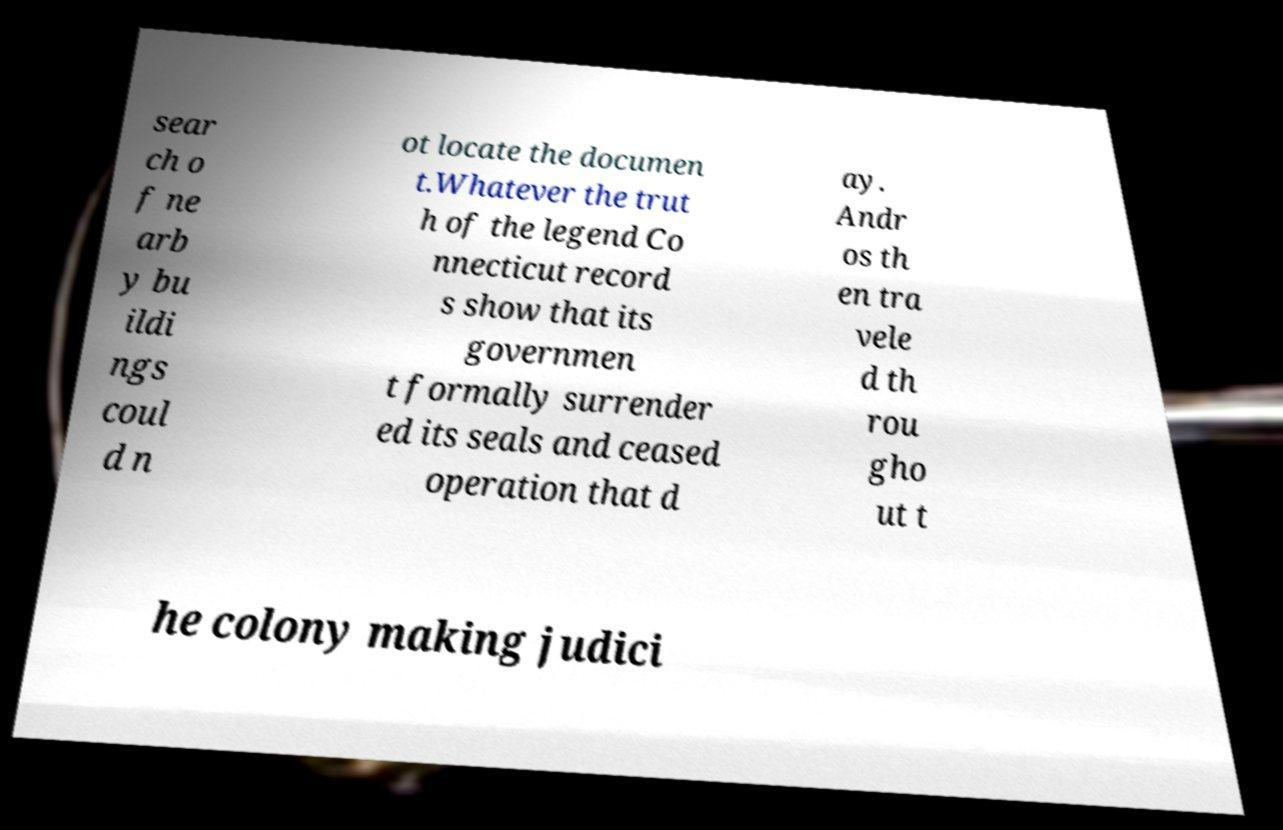Please read and relay the text visible in this image. What does it say? sear ch o f ne arb y bu ildi ngs coul d n ot locate the documen t.Whatever the trut h of the legend Co nnecticut record s show that its governmen t formally surrender ed its seals and ceased operation that d ay. Andr os th en tra vele d th rou gho ut t he colony making judici 